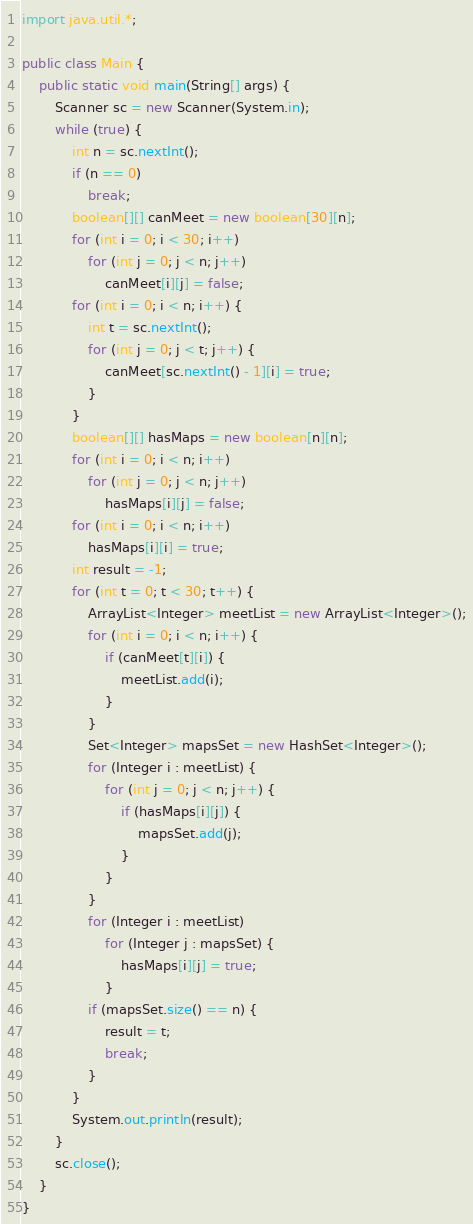<code> <loc_0><loc_0><loc_500><loc_500><_Java_>import java.util.*;

public class Main {
	public static void main(String[] args) {
		Scanner sc = new Scanner(System.in);
		while (true) {
			int n = sc.nextInt();
			if (n == 0)
				break;
			boolean[][] canMeet = new boolean[30][n];
			for (int i = 0; i < 30; i++)
				for (int j = 0; j < n; j++)
					canMeet[i][j] = false;
			for (int i = 0; i < n; i++) {
				int t = sc.nextInt();
				for (int j = 0; j < t; j++) {
					canMeet[sc.nextInt() - 1][i] = true;
				}
			}
			boolean[][] hasMaps = new boolean[n][n];
			for (int i = 0; i < n; i++)
				for (int j = 0; j < n; j++)
					hasMaps[i][j] = false;
			for (int i = 0; i < n; i++)
				hasMaps[i][i] = true;
			int result = -1;
			for (int t = 0; t < 30; t++) {
				ArrayList<Integer> meetList = new ArrayList<Integer>();
				for (int i = 0; i < n; i++) {
					if (canMeet[t][i]) {
						meetList.add(i);
					}
				}
				Set<Integer> mapsSet = new HashSet<Integer>();
				for (Integer i : meetList) {
					for (int j = 0; j < n; j++) {
						if (hasMaps[i][j]) {
							mapsSet.add(j);
						}
					}
				}
				for (Integer i : meetList)
					for (Integer j : mapsSet) {
						hasMaps[i][j] = true;
					}
				if (mapsSet.size() == n) {
					result = t;
					break;
				}
			}
			System.out.println(result);
		}
		sc.close();
	}
}</code> 